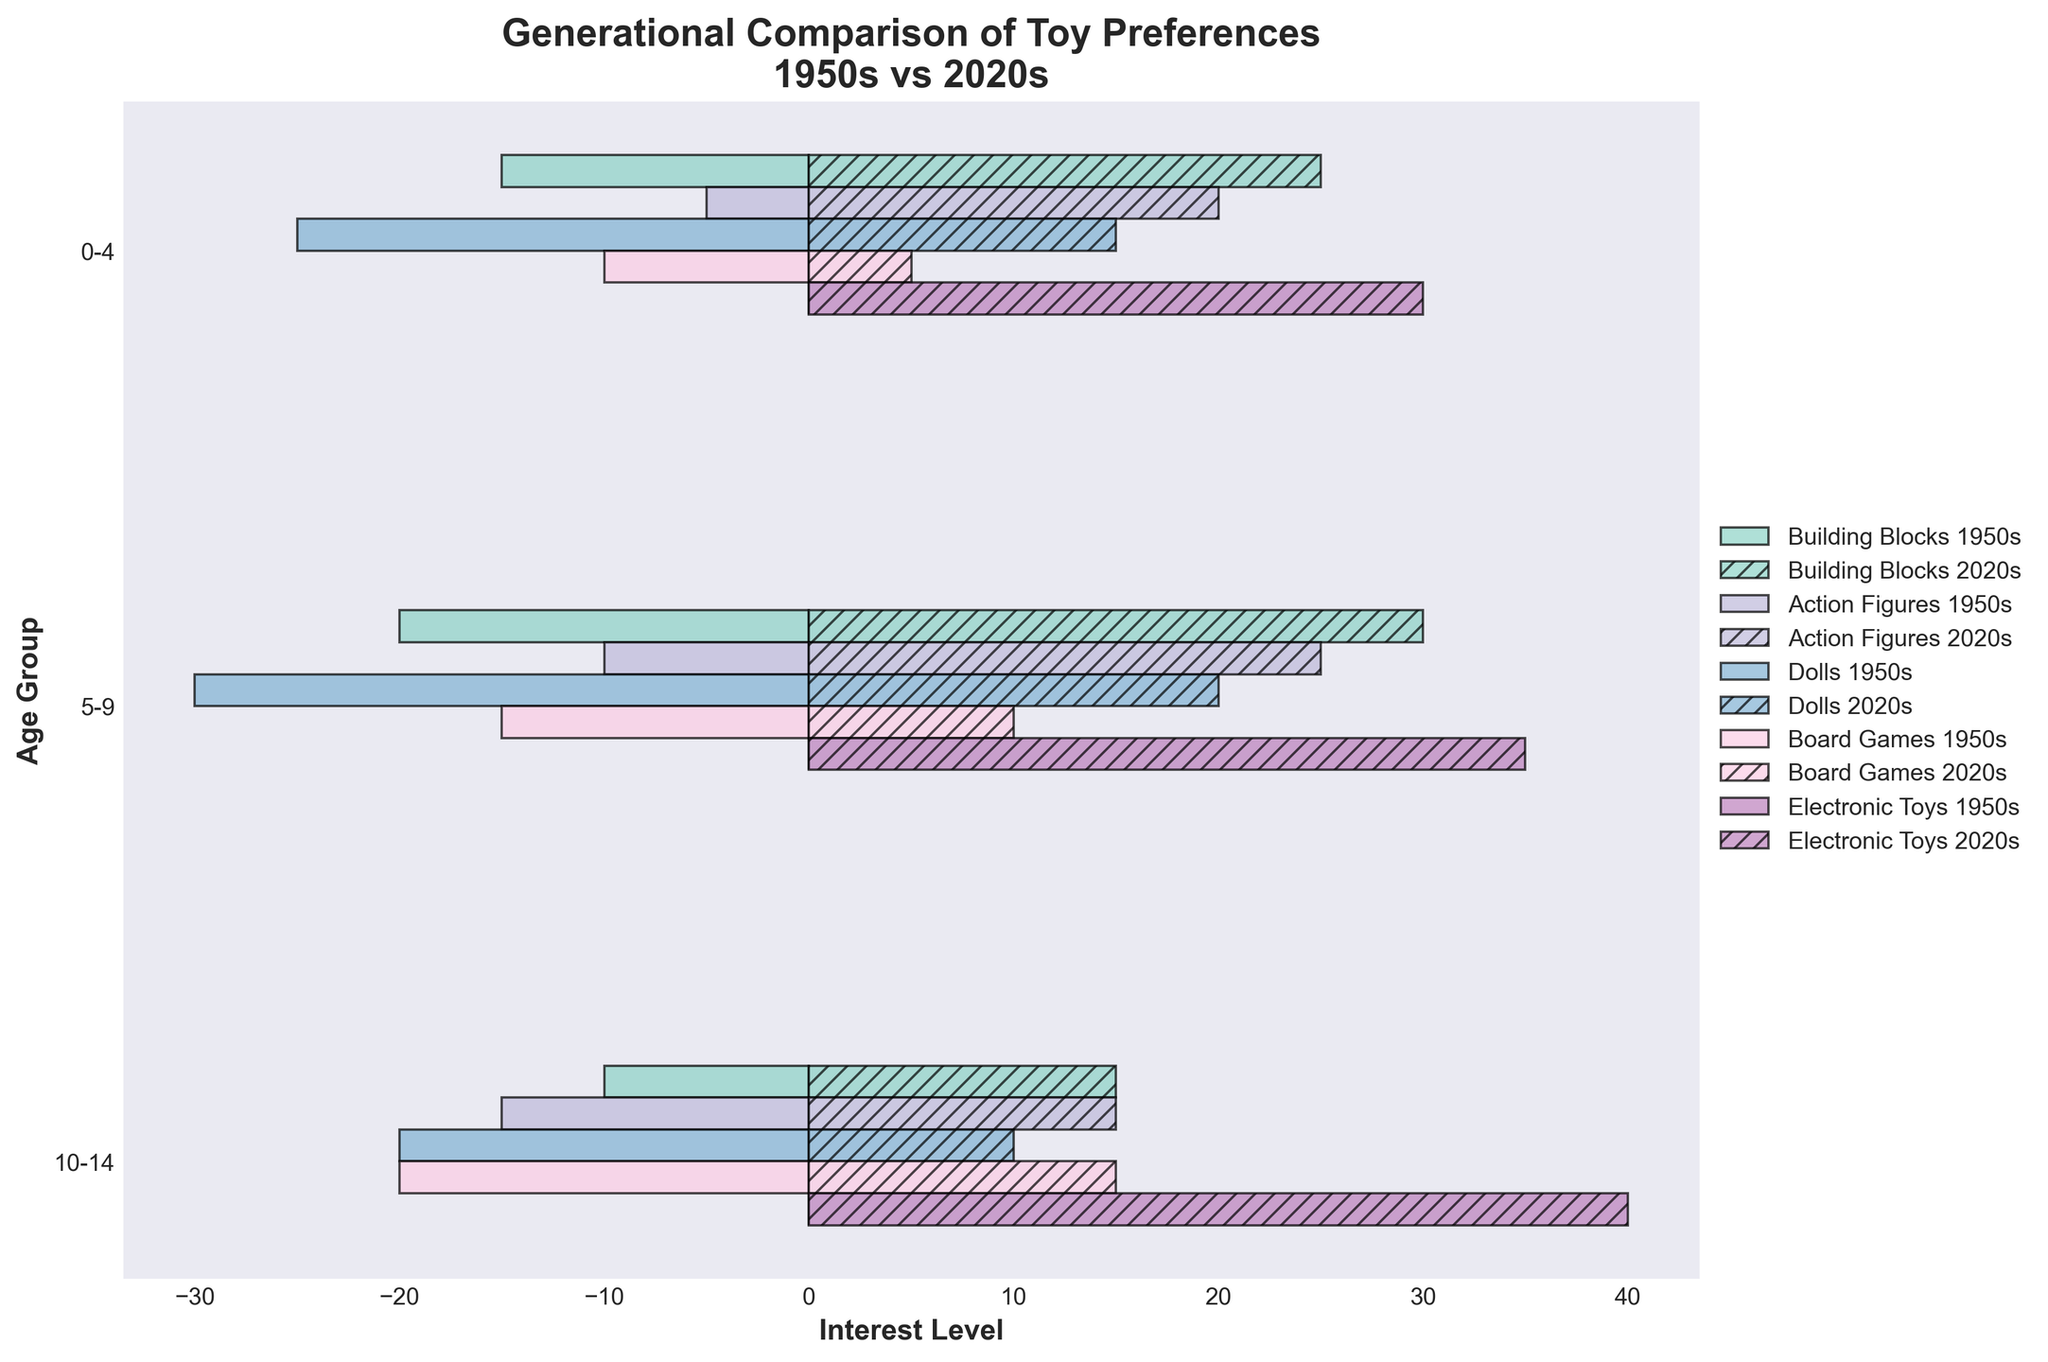What are the toy categories represented in the figure? The figure represents different toy categories. You can identify them by looking at the bars with different colors and hatch patterns in the legend.
Answer: Building Blocks, Action Figures, Dolls, Board Games, Electronic Toys What is the overall title of the figure? The title is found at the top of the figure and provides an overview of what the figure is about.
Answer: Generational Comparison of Toy Preferences: 1950s vs 2020s Which age group in the 2020s shows the highest interest in Electronic Toys? Locate the bars labeled as "Electronic Toys" and refer to their lengths. The longest bar indicates the highest interest.
Answer: 10-14 What is the difference in interest levels for Action Figures between 0-4 age group in the 1950s and 2020s? Compare the length of the Action Figures bar for the 0-4 age group in the '1950s' and '2020s'. Subtract the smaller value from the larger value.
Answer: 15 Which toy category has decreased in popularity from the 1950s to the 2020s among the 0-4 age group? Compare the bar lengths for each toy category in the 0-4 age group between the 1950s and 2020s. Identify which category has a shorter bar in the 2020s.
Answer: Dolls, Board Games How does the interest in Building Blocks for the 5-9 age group in the 2020s compare to the interest level in the same category and age group in the 1950s? Look at the bars representing Building Blocks for the 5-9 age group in both the 1950s and 2020s. Check which bar is longer to compare interest levels.
Answer: Higher in 2020s List the toy categories that the 10-14 age group showed increased interest in from the 1950s to 2020s. Check the bars for each toy category for the 10-14 age group in both time periods. Compare the lengths and list those categories with longer bars in the 2020s.
Answer: Electronic Toys, Board Games What is the combined interest level in Dolls for the age groups 0-4, 5-9, and 10-14 in the 1950s? Sum up the lengths of the bars representing Dolls for all three age groups in the 1950s: 25 (0-4) + 30 (5-9) + 20 (10-14).
Answer: 75 Between the 1950s and 2020s, which age group shows the most significant increase in interest in Electronic Toys? Compare the lengths of the bars representing Electronic Toys for each age group in 1950s and 2020s. The most significant increase is where the difference is the largest.
Answer: 10-14 For the 0-4 age group, how does the interest in Building Blocks compare to the interest in Action Figures in the 2020s? Compare the lengths of the bars representing Building Blocks and Action Figures for the 0-4 age group in the 2020s. Determine which bar is longer.
Answer: Higher for Building Blocks 